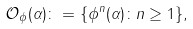<formula> <loc_0><loc_0><loc_500><loc_500>\mathcal { O } _ { \phi } ( \alpha ) \colon = \{ \phi ^ { n } ( \alpha ) \colon n \geq 1 \} ,</formula> 